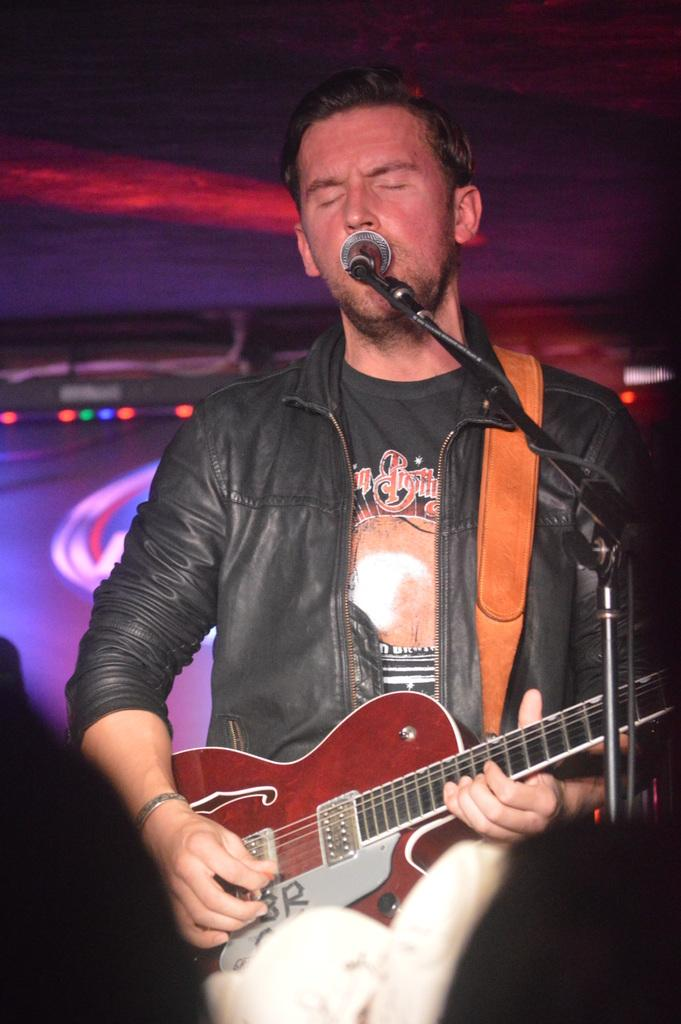What is the man in the image doing? The man is singing in front of a microphone. What instrument is the man holding? The man is holding a guitar. What is the man wearing in the image? The man is wearing a black color jacket. What can be seen in the background of the image? There are lights visible in the background of the image. How many bikes are parked next to the man in the image? There are no bikes present in the image. What type of pump is being used by the man to inflate the guitar? There is no pump visible in the image, and the guitar is not an inflatable object. 